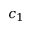Convert formula to latex. <formula><loc_0><loc_0><loc_500><loc_500>c _ { 1 }</formula> 